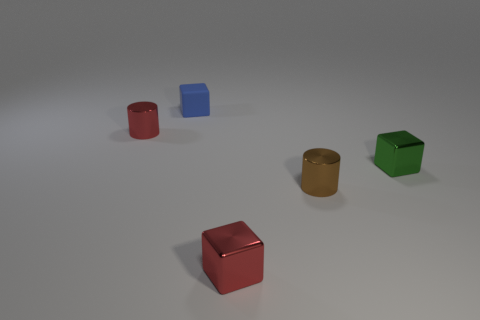Add 2 red things. How many objects exist? 7 Subtract all cylinders. How many objects are left? 3 Add 2 green shiny blocks. How many green shiny blocks are left? 3 Add 2 cylinders. How many cylinders exist? 4 Subtract 0 green spheres. How many objects are left? 5 Subtract all tiny red rubber spheres. Subtract all small matte things. How many objects are left? 4 